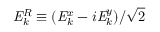Convert formula to latex. <formula><loc_0><loc_0><loc_500><loc_500>{ E } _ { k } ^ { R } \equiv ( { E } _ { k } ^ { x } - i { E } _ { k } ^ { y } ) / \sqrt { 2 }</formula> 